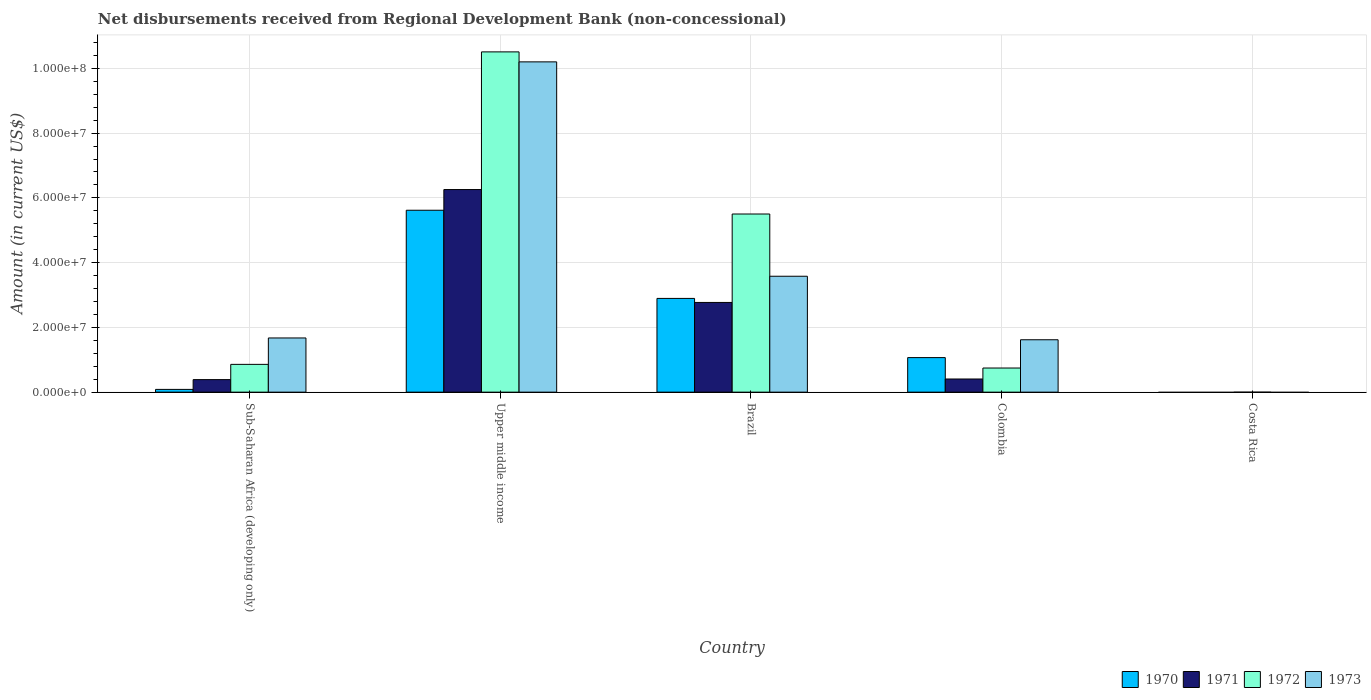How many different coloured bars are there?
Provide a short and direct response. 4. Are the number of bars per tick equal to the number of legend labels?
Your response must be concise. No. Are the number of bars on each tick of the X-axis equal?
Your answer should be very brief. No. How many bars are there on the 4th tick from the left?
Ensure brevity in your answer.  4. In how many cases, is the number of bars for a given country not equal to the number of legend labels?
Keep it short and to the point. 1. What is the amount of disbursements received from Regional Development Bank in 1973 in Upper middle income?
Offer a terse response. 1.02e+08. Across all countries, what is the maximum amount of disbursements received from Regional Development Bank in 1973?
Ensure brevity in your answer.  1.02e+08. In which country was the amount of disbursements received from Regional Development Bank in 1971 maximum?
Your answer should be very brief. Upper middle income. What is the total amount of disbursements received from Regional Development Bank in 1970 in the graph?
Keep it short and to the point. 9.67e+07. What is the difference between the amount of disbursements received from Regional Development Bank in 1972 in Brazil and that in Colombia?
Your answer should be very brief. 4.76e+07. What is the difference between the amount of disbursements received from Regional Development Bank in 1971 in Sub-Saharan Africa (developing only) and the amount of disbursements received from Regional Development Bank in 1972 in Brazil?
Offer a terse response. -5.12e+07. What is the average amount of disbursements received from Regional Development Bank in 1972 per country?
Give a very brief answer. 3.52e+07. What is the difference between the amount of disbursements received from Regional Development Bank of/in 1970 and amount of disbursements received from Regional Development Bank of/in 1973 in Upper middle income?
Ensure brevity in your answer.  -4.58e+07. What is the ratio of the amount of disbursements received from Regional Development Bank in 1971 in Brazil to that in Colombia?
Your answer should be very brief. 6.82. What is the difference between the highest and the second highest amount of disbursements received from Regional Development Bank in 1973?
Your answer should be compact. 8.53e+07. What is the difference between the highest and the lowest amount of disbursements received from Regional Development Bank in 1970?
Give a very brief answer. 5.62e+07. Is the sum of the amount of disbursements received from Regional Development Bank in 1971 in Brazil and Colombia greater than the maximum amount of disbursements received from Regional Development Bank in 1972 across all countries?
Offer a very short reply. No. How many countries are there in the graph?
Your response must be concise. 5. Are the values on the major ticks of Y-axis written in scientific E-notation?
Keep it short and to the point. Yes. Does the graph contain any zero values?
Your answer should be compact. Yes. How many legend labels are there?
Give a very brief answer. 4. How are the legend labels stacked?
Ensure brevity in your answer.  Horizontal. What is the title of the graph?
Provide a succinct answer. Net disbursements received from Regional Development Bank (non-concessional). Does "2005" appear as one of the legend labels in the graph?
Your answer should be very brief. No. What is the label or title of the Y-axis?
Ensure brevity in your answer.  Amount (in current US$). What is the Amount (in current US$) of 1970 in Sub-Saharan Africa (developing only)?
Your answer should be very brief. 8.50e+05. What is the Amount (in current US$) in 1971 in Sub-Saharan Africa (developing only)?
Make the answer very short. 3.87e+06. What is the Amount (in current US$) in 1972 in Sub-Saharan Africa (developing only)?
Offer a terse response. 8.58e+06. What is the Amount (in current US$) of 1973 in Sub-Saharan Africa (developing only)?
Provide a succinct answer. 1.67e+07. What is the Amount (in current US$) in 1970 in Upper middle income?
Provide a short and direct response. 5.62e+07. What is the Amount (in current US$) in 1971 in Upper middle income?
Ensure brevity in your answer.  6.26e+07. What is the Amount (in current US$) in 1972 in Upper middle income?
Ensure brevity in your answer.  1.05e+08. What is the Amount (in current US$) in 1973 in Upper middle income?
Offer a very short reply. 1.02e+08. What is the Amount (in current US$) in 1970 in Brazil?
Make the answer very short. 2.90e+07. What is the Amount (in current US$) of 1971 in Brazil?
Provide a short and direct response. 2.77e+07. What is the Amount (in current US$) of 1972 in Brazil?
Provide a succinct answer. 5.50e+07. What is the Amount (in current US$) in 1973 in Brazil?
Make the answer very short. 3.58e+07. What is the Amount (in current US$) of 1970 in Colombia?
Provide a succinct answer. 1.07e+07. What is the Amount (in current US$) of 1971 in Colombia?
Your answer should be very brief. 4.06e+06. What is the Amount (in current US$) in 1972 in Colombia?
Your response must be concise. 7.45e+06. What is the Amount (in current US$) in 1973 in Colombia?
Your answer should be compact. 1.62e+07. What is the Amount (in current US$) in 1970 in Costa Rica?
Make the answer very short. 0. What is the Amount (in current US$) of 1973 in Costa Rica?
Your answer should be compact. 0. Across all countries, what is the maximum Amount (in current US$) of 1970?
Give a very brief answer. 5.62e+07. Across all countries, what is the maximum Amount (in current US$) of 1971?
Your answer should be very brief. 6.26e+07. Across all countries, what is the maximum Amount (in current US$) of 1972?
Ensure brevity in your answer.  1.05e+08. Across all countries, what is the maximum Amount (in current US$) of 1973?
Ensure brevity in your answer.  1.02e+08. Across all countries, what is the minimum Amount (in current US$) in 1972?
Give a very brief answer. 0. What is the total Amount (in current US$) in 1970 in the graph?
Make the answer very short. 9.67e+07. What is the total Amount (in current US$) in 1971 in the graph?
Offer a very short reply. 9.82e+07. What is the total Amount (in current US$) in 1972 in the graph?
Make the answer very short. 1.76e+08. What is the total Amount (in current US$) in 1973 in the graph?
Give a very brief answer. 1.71e+08. What is the difference between the Amount (in current US$) of 1970 in Sub-Saharan Africa (developing only) and that in Upper middle income?
Keep it short and to the point. -5.53e+07. What is the difference between the Amount (in current US$) in 1971 in Sub-Saharan Africa (developing only) and that in Upper middle income?
Give a very brief answer. -5.87e+07. What is the difference between the Amount (in current US$) of 1972 in Sub-Saharan Africa (developing only) and that in Upper middle income?
Your answer should be compact. -9.65e+07. What is the difference between the Amount (in current US$) of 1973 in Sub-Saharan Africa (developing only) and that in Upper middle income?
Offer a terse response. -8.53e+07. What is the difference between the Amount (in current US$) in 1970 in Sub-Saharan Africa (developing only) and that in Brazil?
Give a very brief answer. -2.81e+07. What is the difference between the Amount (in current US$) in 1971 in Sub-Saharan Africa (developing only) and that in Brazil?
Your response must be concise. -2.38e+07. What is the difference between the Amount (in current US$) of 1972 in Sub-Saharan Africa (developing only) and that in Brazil?
Your answer should be very brief. -4.64e+07. What is the difference between the Amount (in current US$) in 1973 in Sub-Saharan Africa (developing only) and that in Brazil?
Ensure brevity in your answer.  -1.91e+07. What is the difference between the Amount (in current US$) of 1970 in Sub-Saharan Africa (developing only) and that in Colombia?
Provide a short and direct response. -9.82e+06. What is the difference between the Amount (in current US$) in 1971 in Sub-Saharan Africa (developing only) and that in Colombia?
Your answer should be very brief. -1.93e+05. What is the difference between the Amount (in current US$) in 1972 in Sub-Saharan Africa (developing only) and that in Colombia?
Your answer should be very brief. 1.13e+06. What is the difference between the Amount (in current US$) of 1973 in Sub-Saharan Africa (developing only) and that in Colombia?
Your response must be concise. 5.57e+05. What is the difference between the Amount (in current US$) of 1970 in Upper middle income and that in Brazil?
Keep it short and to the point. 2.72e+07. What is the difference between the Amount (in current US$) of 1971 in Upper middle income and that in Brazil?
Your answer should be very brief. 3.49e+07. What is the difference between the Amount (in current US$) of 1972 in Upper middle income and that in Brazil?
Give a very brief answer. 5.01e+07. What is the difference between the Amount (in current US$) in 1973 in Upper middle income and that in Brazil?
Your answer should be very brief. 6.62e+07. What is the difference between the Amount (in current US$) in 1970 in Upper middle income and that in Colombia?
Give a very brief answer. 4.55e+07. What is the difference between the Amount (in current US$) in 1971 in Upper middle income and that in Colombia?
Provide a succinct answer. 5.85e+07. What is the difference between the Amount (in current US$) of 1972 in Upper middle income and that in Colombia?
Ensure brevity in your answer.  9.76e+07. What is the difference between the Amount (in current US$) of 1973 in Upper middle income and that in Colombia?
Your answer should be very brief. 8.58e+07. What is the difference between the Amount (in current US$) of 1970 in Brazil and that in Colombia?
Give a very brief answer. 1.83e+07. What is the difference between the Amount (in current US$) in 1971 in Brazil and that in Colombia?
Provide a succinct answer. 2.36e+07. What is the difference between the Amount (in current US$) in 1972 in Brazil and that in Colombia?
Your answer should be very brief. 4.76e+07. What is the difference between the Amount (in current US$) of 1973 in Brazil and that in Colombia?
Provide a short and direct response. 1.96e+07. What is the difference between the Amount (in current US$) in 1970 in Sub-Saharan Africa (developing only) and the Amount (in current US$) in 1971 in Upper middle income?
Make the answer very short. -6.17e+07. What is the difference between the Amount (in current US$) of 1970 in Sub-Saharan Africa (developing only) and the Amount (in current US$) of 1972 in Upper middle income?
Make the answer very short. -1.04e+08. What is the difference between the Amount (in current US$) of 1970 in Sub-Saharan Africa (developing only) and the Amount (in current US$) of 1973 in Upper middle income?
Keep it short and to the point. -1.01e+08. What is the difference between the Amount (in current US$) in 1971 in Sub-Saharan Africa (developing only) and the Amount (in current US$) in 1972 in Upper middle income?
Make the answer very short. -1.01e+08. What is the difference between the Amount (in current US$) of 1971 in Sub-Saharan Africa (developing only) and the Amount (in current US$) of 1973 in Upper middle income?
Ensure brevity in your answer.  -9.81e+07. What is the difference between the Amount (in current US$) in 1972 in Sub-Saharan Africa (developing only) and the Amount (in current US$) in 1973 in Upper middle income?
Ensure brevity in your answer.  -9.34e+07. What is the difference between the Amount (in current US$) in 1970 in Sub-Saharan Africa (developing only) and the Amount (in current US$) in 1971 in Brazil?
Offer a very short reply. -2.69e+07. What is the difference between the Amount (in current US$) of 1970 in Sub-Saharan Africa (developing only) and the Amount (in current US$) of 1972 in Brazil?
Keep it short and to the point. -5.42e+07. What is the difference between the Amount (in current US$) of 1970 in Sub-Saharan Africa (developing only) and the Amount (in current US$) of 1973 in Brazil?
Make the answer very short. -3.50e+07. What is the difference between the Amount (in current US$) in 1971 in Sub-Saharan Africa (developing only) and the Amount (in current US$) in 1972 in Brazil?
Provide a short and direct response. -5.12e+07. What is the difference between the Amount (in current US$) of 1971 in Sub-Saharan Africa (developing only) and the Amount (in current US$) of 1973 in Brazil?
Offer a very short reply. -3.19e+07. What is the difference between the Amount (in current US$) of 1972 in Sub-Saharan Africa (developing only) and the Amount (in current US$) of 1973 in Brazil?
Give a very brief answer. -2.72e+07. What is the difference between the Amount (in current US$) in 1970 in Sub-Saharan Africa (developing only) and the Amount (in current US$) in 1971 in Colombia?
Keep it short and to the point. -3.21e+06. What is the difference between the Amount (in current US$) of 1970 in Sub-Saharan Africa (developing only) and the Amount (in current US$) of 1972 in Colombia?
Provide a short and direct response. -6.60e+06. What is the difference between the Amount (in current US$) in 1970 in Sub-Saharan Africa (developing only) and the Amount (in current US$) in 1973 in Colombia?
Offer a terse response. -1.53e+07. What is the difference between the Amount (in current US$) in 1971 in Sub-Saharan Africa (developing only) and the Amount (in current US$) in 1972 in Colombia?
Ensure brevity in your answer.  -3.58e+06. What is the difference between the Amount (in current US$) in 1971 in Sub-Saharan Africa (developing only) and the Amount (in current US$) in 1973 in Colombia?
Keep it short and to the point. -1.23e+07. What is the difference between the Amount (in current US$) of 1972 in Sub-Saharan Africa (developing only) and the Amount (in current US$) of 1973 in Colombia?
Ensure brevity in your answer.  -7.60e+06. What is the difference between the Amount (in current US$) of 1970 in Upper middle income and the Amount (in current US$) of 1971 in Brazil?
Offer a very short reply. 2.85e+07. What is the difference between the Amount (in current US$) in 1970 in Upper middle income and the Amount (in current US$) in 1972 in Brazil?
Offer a terse response. 1.16e+06. What is the difference between the Amount (in current US$) in 1970 in Upper middle income and the Amount (in current US$) in 1973 in Brazil?
Offer a terse response. 2.04e+07. What is the difference between the Amount (in current US$) of 1971 in Upper middle income and the Amount (in current US$) of 1972 in Brazil?
Provide a short and direct response. 7.55e+06. What is the difference between the Amount (in current US$) in 1971 in Upper middle income and the Amount (in current US$) in 1973 in Brazil?
Offer a very short reply. 2.68e+07. What is the difference between the Amount (in current US$) in 1972 in Upper middle income and the Amount (in current US$) in 1973 in Brazil?
Your response must be concise. 6.93e+07. What is the difference between the Amount (in current US$) in 1970 in Upper middle income and the Amount (in current US$) in 1971 in Colombia?
Offer a very short reply. 5.21e+07. What is the difference between the Amount (in current US$) of 1970 in Upper middle income and the Amount (in current US$) of 1972 in Colombia?
Ensure brevity in your answer.  4.87e+07. What is the difference between the Amount (in current US$) of 1970 in Upper middle income and the Amount (in current US$) of 1973 in Colombia?
Offer a terse response. 4.00e+07. What is the difference between the Amount (in current US$) in 1971 in Upper middle income and the Amount (in current US$) in 1972 in Colombia?
Offer a terse response. 5.51e+07. What is the difference between the Amount (in current US$) of 1971 in Upper middle income and the Amount (in current US$) of 1973 in Colombia?
Your answer should be compact. 4.64e+07. What is the difference between the Amount (in current US$) in 1972 in Upper middle income and the Amount (in current US$) in 1973 in Colombia?
Ensure brevity in your answer.  8.89e+07. What is the difference between the Amount (in current US$) in 1970 in Brazil and the Amount (in current US$) in 1971 in Colombia?
Offer a very short reply. 2.49e+07. What is the difference between the Amount (in current US$) in 1970 in Brazil and the Amount (in current US$) in 1972 in Colombia?
Provide a short and direct response. 2.15e+07. What is the difference between the Amount (in current US$) in 1970 in Brazil and the Amount (in current US$) in 1973 in Colombia?
Your answer should be very brief. 1.28e+07. What is the difference between the Amount (in current US$) in 1971 in Brazil and the Amount (in current US$) in 1972 in Colombia?
Provide a short and direct response. 2.03e+07. What is the difference between the Amount (in current US$) in 1971 in Brazil and the Amount (in current US$) in 1973 in Colombia?
Your answer should be very brief. 1.15e+07. What is the difference between the Amount (in current US$) in 1972 in Brazil and the Amount (in current US$) in 1973 in Colombia?
Offer a terse response. 3.88e+07. What is the average Amount (in current US$) in 1970 per country?
Keep it short and to the point. 1.93e+07. What is the average Amount (in current US$) in 1971 per country?
Keep it short and to the point. 1.96e+07. What is the average Amount (in current US$) in 1972 per country?
Provide a succinct answer. 3.52e+07. What is the average Amount (in current US$) of 1973 per country?
Offer a very short reply. 3.41e+07. What is the difference between the Amount (in current US$) in 1970 and Amount (in current US$) in 1971 in Sub-Saharan Africa (developing only)?
Offer a very short reply. -3.02e+06. What is the difference between the Amount (in current US$) in 1970 and Amount (in current US$) in 1972 in Sub-Saharan Africa (developing only)?
Keep it short and to the point. -7.73e+06. What is the difference between the Amount (in current US$) of 1970 and Amount (in current US$) of 1973 in Sub-Saharan Africa (developing only)?
Provide a succinct answer. -1.59e+07. What is the difference between the Amount (in current US$) in 1971 and Amount (in current US$) in 1972 in Sub-Saharan Africa (developing only)?
Make the answer very short. -4.71e+06. What is the difference between the Amount (in current US$) in 1971 and Amount (in current US$) in 1973 in Sub-Saharan Africa (developing only)?
Provide a short and direct response. -1.29e+07. What is the difference between the Amount (in current US$) in 1972 and Amount (in current US$) in 1973 in Sub-Saharan Africa (developing only)?
Offer a very short reply. -8.16e+06. What is the difference between the Amount (in current US$) in 1970 and Amount (in current US$) in 1971 in Upper middle income?
Provide a short and direct response. -6.39e+06. What is the difference between the Amount (in current US$) of 1970 and Amount (in current US$) of 1972 in Upper middle income?
Keep it short and to the point. -4.89e+07. What is the difference between the Amount (in current US$) of 1970 and Amount (in current US$) of 1973 in Upper middle income?
Offer a very short reply. -4.58e+07. What is the difference between the Amount (in current US$) in 1971 and Amount (in current US$) in 1972 in Upper middle income?
Make the answer very short. -4.25e+07. What is the difference between the Amount (in current US$) in 1971 and Amount (in current US$) in 1973 in Upper middle income?
Your answer should be very brief. -3.94e+07. What is the difference between the Amount (in current US$) in 1972 and Amount (in current US$) in 1973 in Upper middle income?
Your answer should be compact. 3.08e+06. What is the difference between the Amount (in current US$) in 1970 and Amount (in current US$) in 1971 in Brazil?
Offer a very short reply. 1.25e+06. What is the difference between the Amount (in current US$) of 1970 and Amount (in current US$) of 1972 in Brazil?
Offer a terse response. -2.61e+07. What is the difference between the Amount (in current US$) of 1970 and Amount (in current US$) of 1973 in Brazil?
Make the answer very short. -6.85e+06. What is the difference between the Amount (in current US$) of 1971 and Amount (in current US$) of 1972 in Brazil?
Your answer should be very brief. -2.73e+07. What is the difference between the Amount (in current US$) of 1971 and Amount (in current US$) of 1973 in Brazil?
Give a very brief answer. -8.10e+06. What is the difference between the Amount (in current US$) in 1972 and Amount (in current US$) in 1973 in Brazil?
Ensure brevity in your answer.  1.92e+07. What is the difference between the Amount (in current US$) in 1970 and Amount (in current US$) in 1971 in Colombia?
Offer a very short reply. 6.61e+06. What is the difference between the Amount (in current US$) in 1970 and Amount (in current US$) in 1972 in Colombia?
Make the answer very short. 3.22e+06. What is the difference between the Amount (in current US$) of 1970 and Amount (in current US$) of 1973 in Colombia?
Provide a short and direct response. -5.51e+06. What is the difference between the Amount (in current US$) of 1971 and Amount (in current US$) of 1972 in Colombia?
Provide a short and direct response. -3.39e+06. What is the difference between the Amount (in current US$) of 1971 and Amount (in current US$) of 1973 in Colombia?
Provide a short and direct response. -1.21e+07. What is the difference between the Amount (in current US$) in 1972 and Amount (in current US$) in 1973 in Colombia?
Offer a terse response. -8.73e+06. What is the ratio of the Amount (in current US$) in 1970 in Sub-Saharan Africa (developing only) to that in Upper middle income?
Make the answer very short. 0.02. What is the ratio of the Amount (in current US$) in 1971 in Sub-Saharan Africa (developing only) to that in Upper middle income?
Offer a very short reply. 0.06. What is the ratio of the Amount (in current US$) of 1972 in Sub-Saharan Africa (developing only) to that in Upper middle income?
Offer a terse response. 0.08. What is the ratio of the Amount (in current US$) of 1973 in Sub-Saharan Africa (developing only) to that in Upper middle income?
Offer a terse response. 0.16. What is the ratio of the Amount (in current US$) in 1970 in Sub-Saharan Africa (developing only) to that in Brazil?
Keep it short and to the point. 0.03. What is the ratio of the Amount (in current US$) in 1971 in Sub-Saharan Africa (developing only) to that in Brazil?
Provide a succinct answer. 0.14. What is the ratio of the Amount (in current US$) of 1972 in Sub-Saharan Africa (developing only) to that in Brazil?
Your answer should be very brief. 0.16. What is the ratio of the Amount (in current US$) in 1973 in Sub-Saharan Africa (developing only) to that in Brazil?
Give a very brief answer. 0.47. What is the ratio of the Amount (in current US$) of 1970 in Sub-Saharan Africa (developing only) to that in Colombia?
Provide a short and direct response. 0.08. What is the ratio of the Amount (in current US$) in 1971 in Sub-Saharan Africa (developing only) to that in Colombia?
Your response must be concise. 0.95. What is the ratio of the Amount (in current US$) in 1972 in Sub-Saharan Africa (developing only) to that in Colombia?
Make the answer very short. 1.15. What is the ratio of the Amount (in current US$) in 1973 in Sub-Saharan Africa (developing only) to that in Colombia?
Make the answer very short. 1.03. What is the ratio of the Amount (in current US$) of 1970 in Upper middle income to that in Brazil?
Your response must be concise. 1.94. What is the ratio of the Amount (in current US$) in 1971 in Upper middle income to that in Brazil?
Keep it short and to the point. 2.26. What is the ratio of the Amount (in current US$) of 1972 in Upper middle income to that in Brazil?
Ensure brevity in your answer.  1.91. What is the ratio of the Amount (in current US$) of 1973 in Upper middle income to that in Brazil?
Provide a short and direct response. 2.85. What is the ratio of the Amount (in current US$) in 1970 in Upper middle income to that in Colombia?
Offer a terse response. 5.27. What is the ratio of the Amount (in current US$) in 1971 in Upper middle income to that in Colombia?
Your answer should be very brief. 15.4. What is the ratio of the Amount (in current US$) of 1972 in Upper middle income to that in Colombia?
Offer a very short reply. 14.11. What is the ratio of the Amount (in current US$) in 1973 in Upper middle income to that in Colombia?
Offer a terse response. 6.3. What is the ratio of the Amount (in current US$) in 1970 in Brazil to that in Colombia?
Provide a succinct answer. 2.71. What is the ratio of the Amount (in current US$) of 1971 in Brazil to that in Colombia?
Provide a short and direct response. 6.82. What is the ratio of the Amount (in current US$) in 1972 in Brazil to that in Colombia?
Your answer should be very brief. 7.39. What is the ratio of the Amount (in current US$) in 1973 in Brazil to that in Colombia?
Make the answer very short. 2.21. What is the difference between the highest and the second highest Amount (in current US$) of 1970?
Keep it short and to the point. 2.72e+07. What is the difference between the highest and the second highest Amount (in current US$) in 1971?
Make the answer very short. 3.49e+07. What is the difference between the highest and the second highest Amount (in current US$) in 1972?
Provide a short and direct response. 5.01e+07. What is the difference between the highest and the second highest Amount (in current US$) of 1973?
Keep it short and to the point. 6.62e+07. What is the difference between the highest and the lowest Amount (in current US$) of 1970?
Offer a very short reply. 5.62e+07. What is the difference between the highest and the lowest Amount (in current US$) of 1971?
Your answer should be very brief. 6.26e+07. What is the difference between the highest and the lowest Amount (in current US$) of 1972?
Your answer should be very brief. 1.05e+08. What is the difference between the highest and the lowest Amount (in current US$) of 1973?
Ensure brevity in your answer.  1.02e+08. 